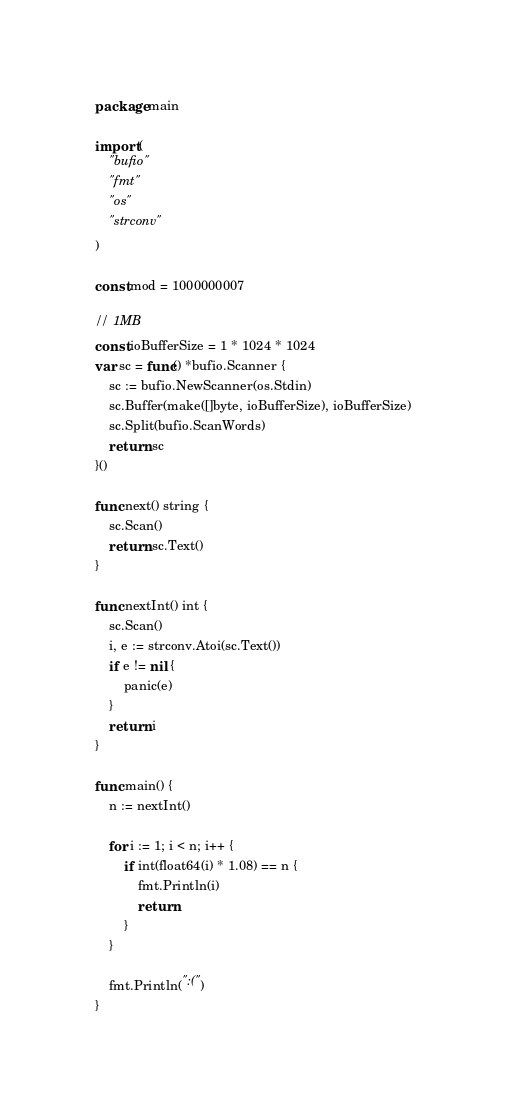<code> <loc_0><loc_0><loc_500><loc_500><_Go_>package main

import (
	"bufio"
	"fmt"
	"os"
	"strconv"
)

const mod = 1000000007

// 1MB
const ioBufferSize = 1 * 1024 * 1024
var sc = func() *bufio.Scanner {
	sc := bufio.NewScanner(os.Stdin)
	sc.Buffer(make([]byte, ioBufferSize), ioBufferSize)
	sc.Split(bufio.ScanWords)
	return sc
}()

func next() string {
	sc.Scan()
	return sc.Text()
}

func nextInt() int {
	sc.Scan()
	i, e := strconv.Atoi(sc.Text())
	if e != nil {
		panic(e)
	}
	return i
}

func main() {
	n := nextInt()

	for i := 1; i < n; i++ {
		if int(float64(i) * 1.08) == n {
			fmt.Println(i)
			return
		}
	}

	fmt.Println(":(")
}</code> 